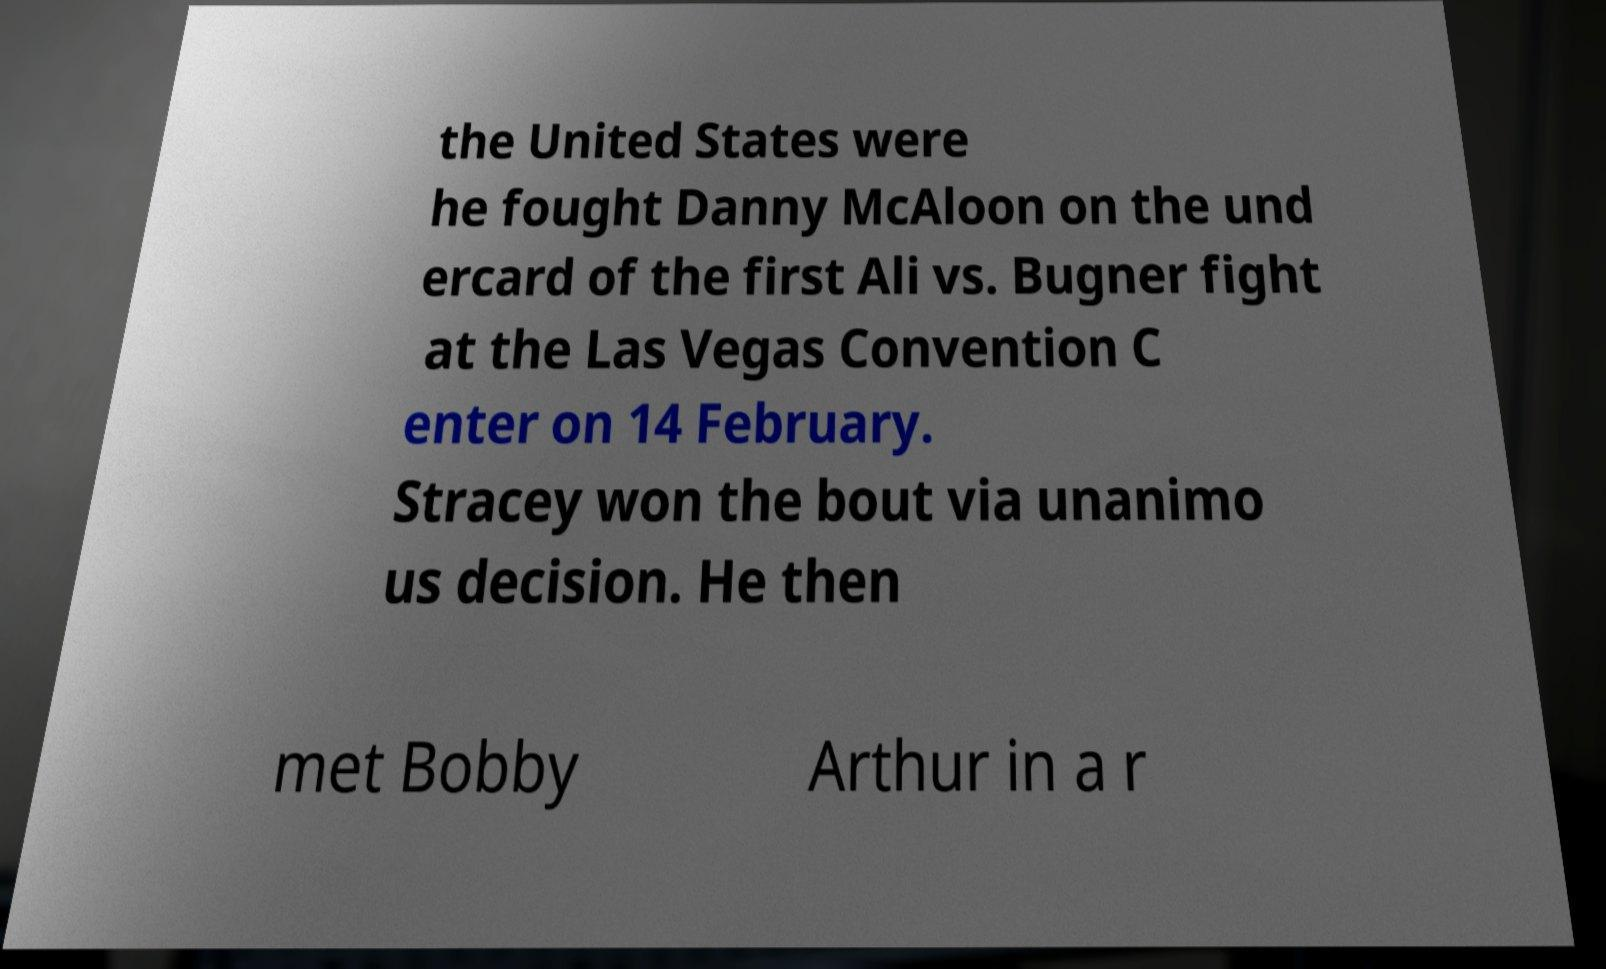Can you read and provide the text displayed in the image?This photo seems to have some interesting text. Can you extract and type it out for me? the United States were he fought Danny McAloon on the und ercard of the first Ali vs. Bugner fight at the Las Vegas Convention C enter on 14 February. Stracey won the bout via unanimo us decision. He then met Bobby Arthur in a r 